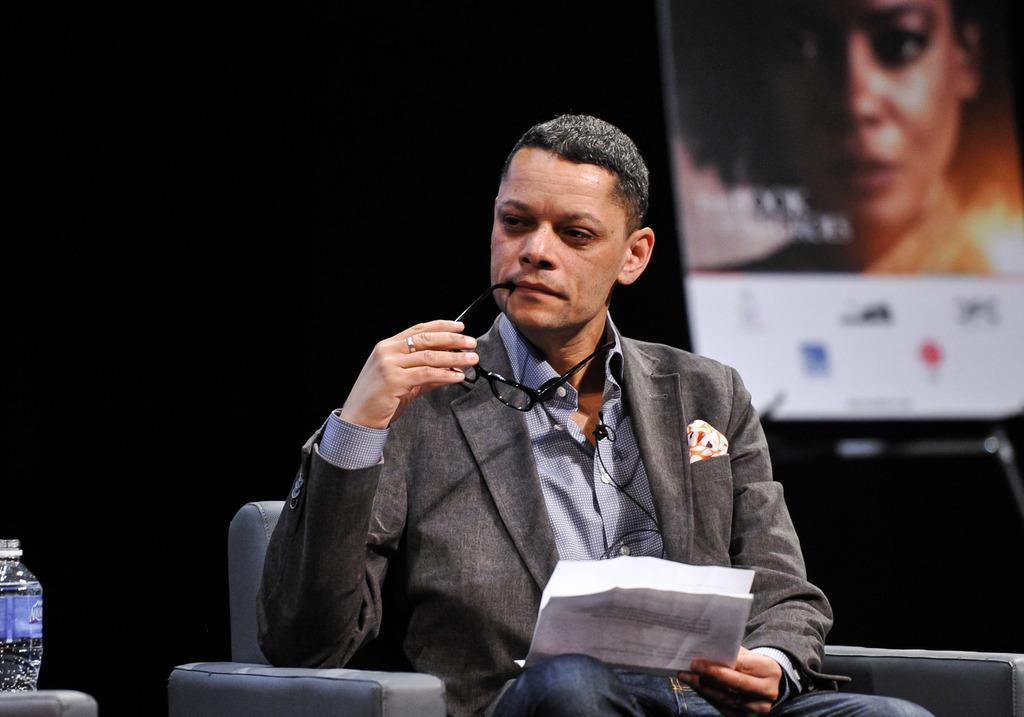Describe this image in one or two sentences. Here I can see a man sitting on a chair, holding few papers and spectacles in the hands and the looking at the left side. On the left side there is a bottle. On the right side there is a screen on which I can see a person's head. The background is in black color. 